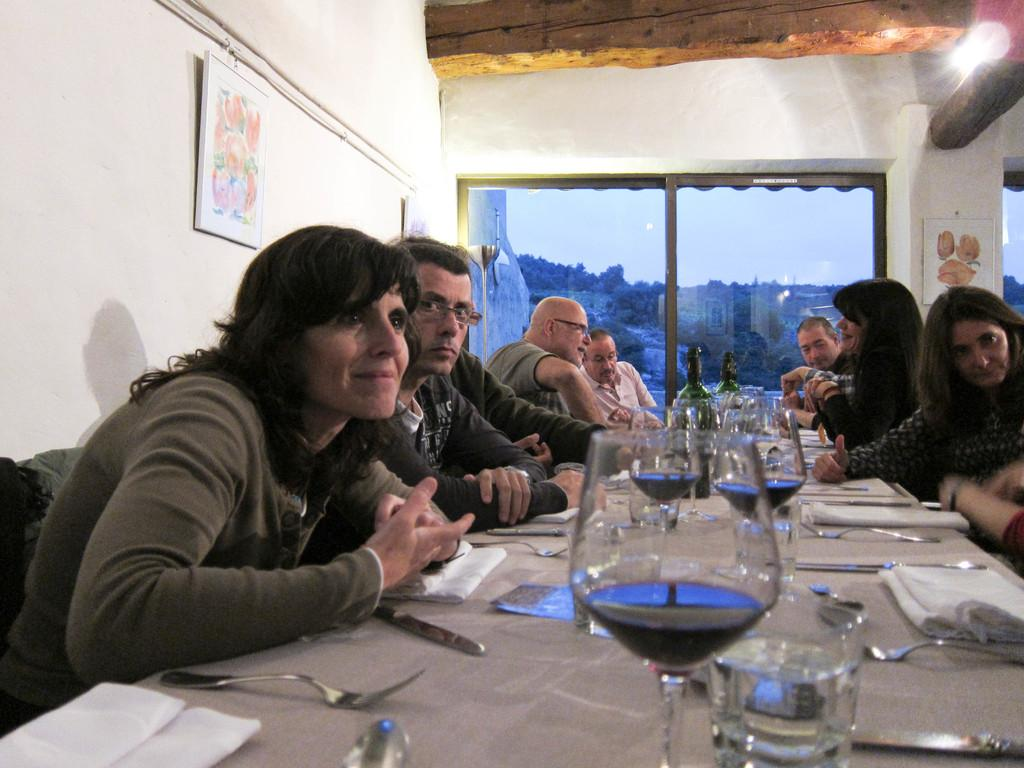What are the people in the image doing? There is a group of people sitting together in the image. Where are the people sitting? They are sitting around a table. What items can be seen on the table? There are wine glasses, forks, and knives on the table. What is the unique feature of the table? There is a window in the middle of the table. What can be seen at the top of the image? There is light at the top of the image. What town is visible through the window in the image? There is no town visible through the window in the image; it is a window in the middle of the table. How many births are taking place in the image? There is no indication of any births taking place in the image. 